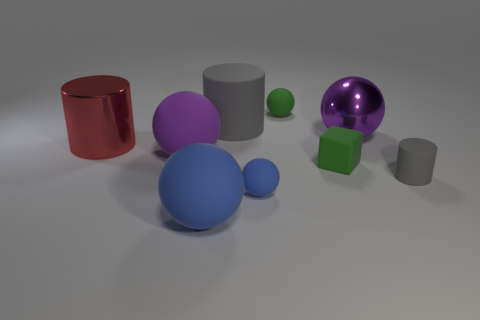What color is the shiny thing on the left side of the gray cylinder that is to the left of the small green cube?
Your response must be concise. Red. There is another rubber sphere that is the same size as the green ball; what color is it?
Offer a very short reply. Blue. What number of metallic objects are either big gray objects or big red objects?
Ensure brevity in your answer.  1. There is a large purple sphere to the right of the large blue ball; what number of rubber cylinders are right of it?
Your answer should be compact. 1. There is a thing that is the same color as the small matte cylinder; what is its size?
Offer a terse response. Large. What number of things are either blue things or big objects to the right of the big blue sphere?
Give a very brief answer. 4. Are there any gray spheres made of the same material as the large gray thing?
Offer a terse response. No. What number of objects are both in front of the big gray rubber cylinder and behind the large blue thing?
Keep it short and to the point. 6. There is a large purple object left of the big shiny ball; what is it made of?
Your response must be concise. Rubber. There is a purple sphere that is made of the same material as the tiny gray thing; what is its size?
Your response must be concise. Large. 